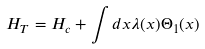<formula> <loc_0><loc_0><loc_500><loc_500>H _ { T } = H _ { c } + \int d x \lambda ( x ) \Theta _ { 1 } ( x )</formula> 